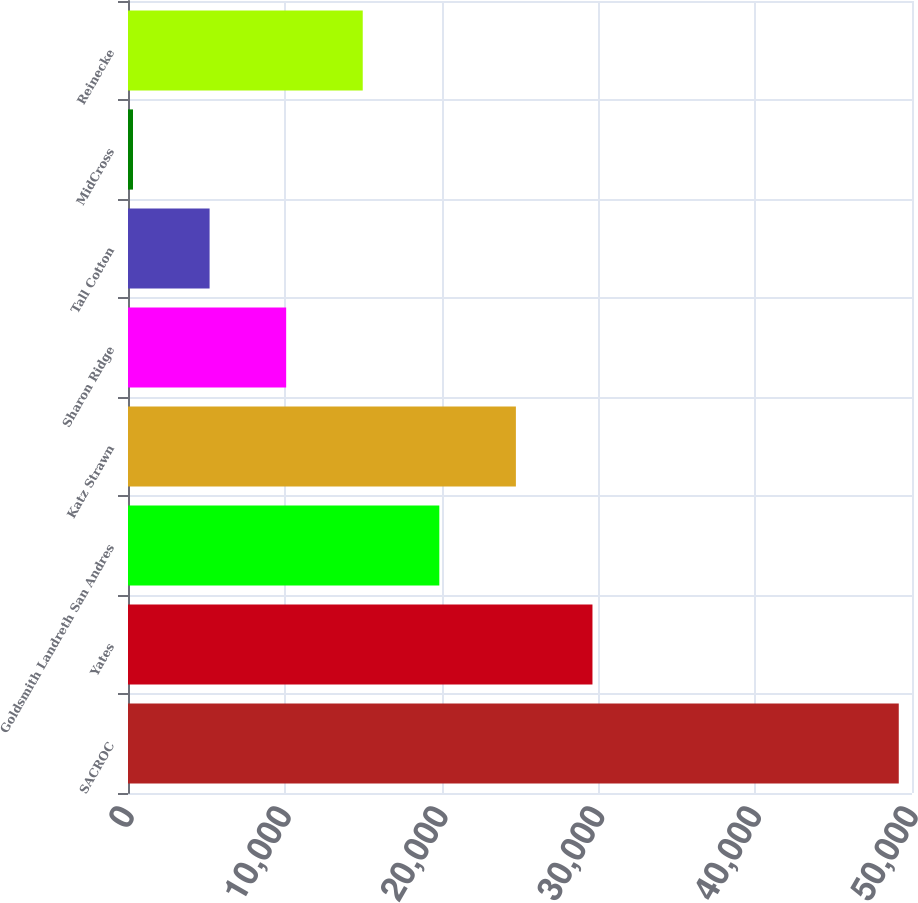Convert chart. <chart><loc_0><loc_0><loc_500><loc_500><bar_chart><fcel>SACROC<fcel>Yates<fcel>Goldsmith Landreth San Andres<fcel>Katz Strawn<fcel>Sharon Ridge<fcel>Tall Cotton<fcel>MidCross<fcel>Reinecke<nl><fcel>49156<fcel>29621.6<fcel>19854.4<fcel>24738<fcel>10087.2<fcel>5203.6<fcel>320<fcel>14970.8<nl></chart> 